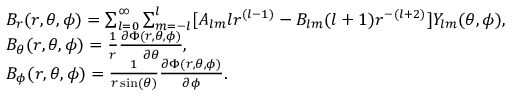<formula> <loc_0><loc_0><loc_500><loc_500>\begin{array} { r l } & { B _ { r } ( r , \theta , \phi ) = \sum _ { l = 0 } ^ { \infty } \sum _ { m = - l } ^ { l } [ A _ { l m } l r ^ { ( l - 1 ) } - B _ { l m } ( l + 1 ) r ^ { - ( l + 2 ) } ] Y _ { l m } ( \theta , \phi ) , } \\ & { B _ { \theta } ( r , \theta , \phi ) = \frac { 1 } { r } \frac { \partial \Phi ( r , \theta , \phi ) } { \partial \theta } , } \\ & { B _ { \phi } ( r , \theta , \phi ) = \frac { 1 } r \sin ( \theta ) } \frac { \partial \Phi ( r , \theta , \phi ) } { \partial \phi } . } \end{array}</formula> 